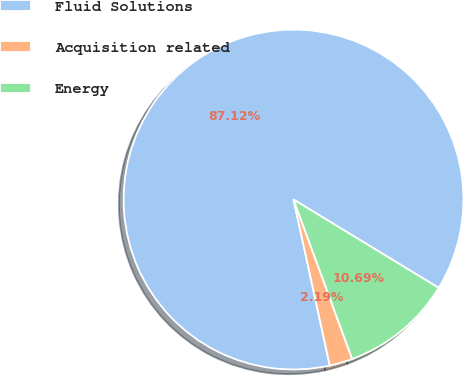Convert chart. <chart><loc_0><loc_0><loc_500><loc_500><pie_chart><fcel>Fluid Solutions<fcel>Acquisition related<fcel>Energy<nl><fcel>87.13%<fcel>2.19%<fcel>10.69%<nl></chart> 